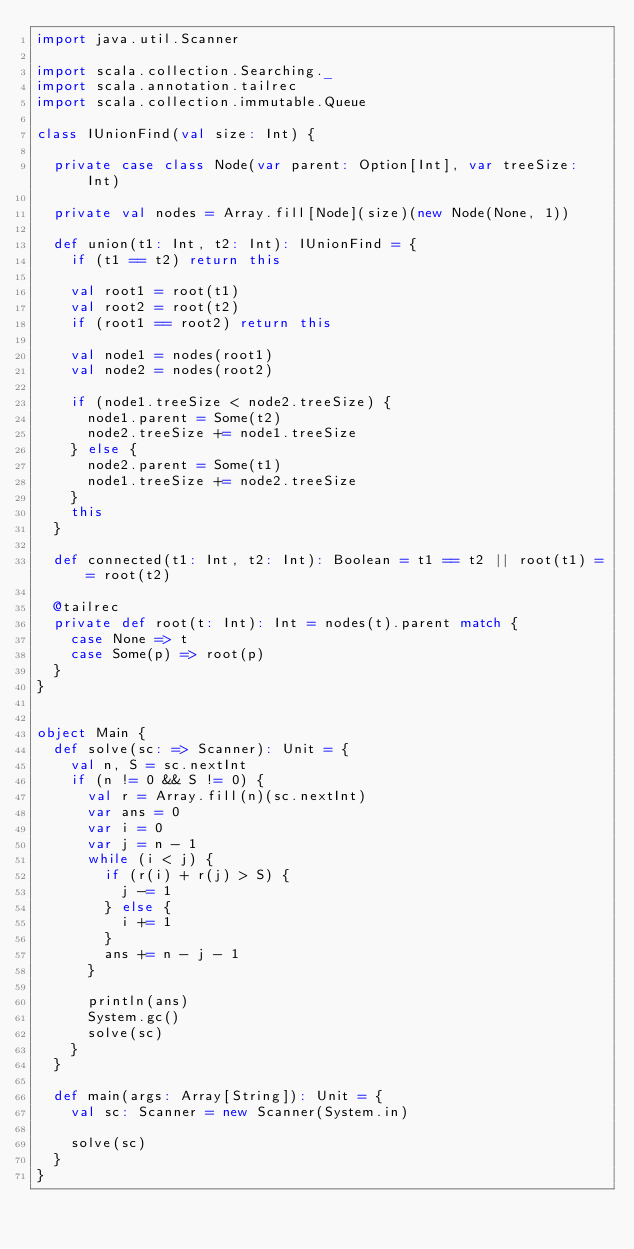Convert code to text. <code><loc_0><loc_0><loc_500><loc_500><_Scala_>import java.util.Scanner

import scala.collection.Searching._
import scala.annotation.tailrec
import scala.collection.immutable.Queue

class IUnionFind(val size: Int) {

  private case class Node(var parent: Option[Int], var treeSize: Int)

  private val nodes = Array.fill[Node](size)(new Node(None, 1))

  def union(t1: Int, t2: Int): IUnionFind = {
    if (t1 == t2) return this

    val root1 = root(t1)
    val root2 = root(t2)
    if (root1 == root2) return this

    val node1 = nodes(root1)
    val node2 = nodes(root2)

    if (node1.treeSize < node2.treeSize) {
      node1.parent = Some(t2)
      node2.treeSize += node1.treeSize
    } else {
      node2.parent = Some(t1)
      node1.treeSize += node2.treeSize
    }
    this
  }

  def connected(t1: Int, t2: Int): Boolean = t1 == t2 || root(t1) == root(t2)

  @tailrec
  private def root(t: Int): Int = nodes(t).parent match {
    case None => t
    case Some(p) => root(p)
  }
}


object Main {
  def solve(sc: => Scanner): Unit = {
    val n, S = sc.nextInt
    if (n != 0 && S != 0) {
      val r = Array.fill(n)(sc.nextInt)
      var ans = 0
      var i = 0
      var j = n - 1
      while (i < j) {
        if (r(i) + r(j) > S) {
          j -= 1
        } else {
          i += 1
        }
        ans += n - j - 1
      }

      println(ans)
      System.gc()
      solve(sc)
    }
  }

  def main(args: Array[String]): Unit = {
    val sc: Scanner = new Scanner(System.in)

    solve(sc)
  }
}</code> 